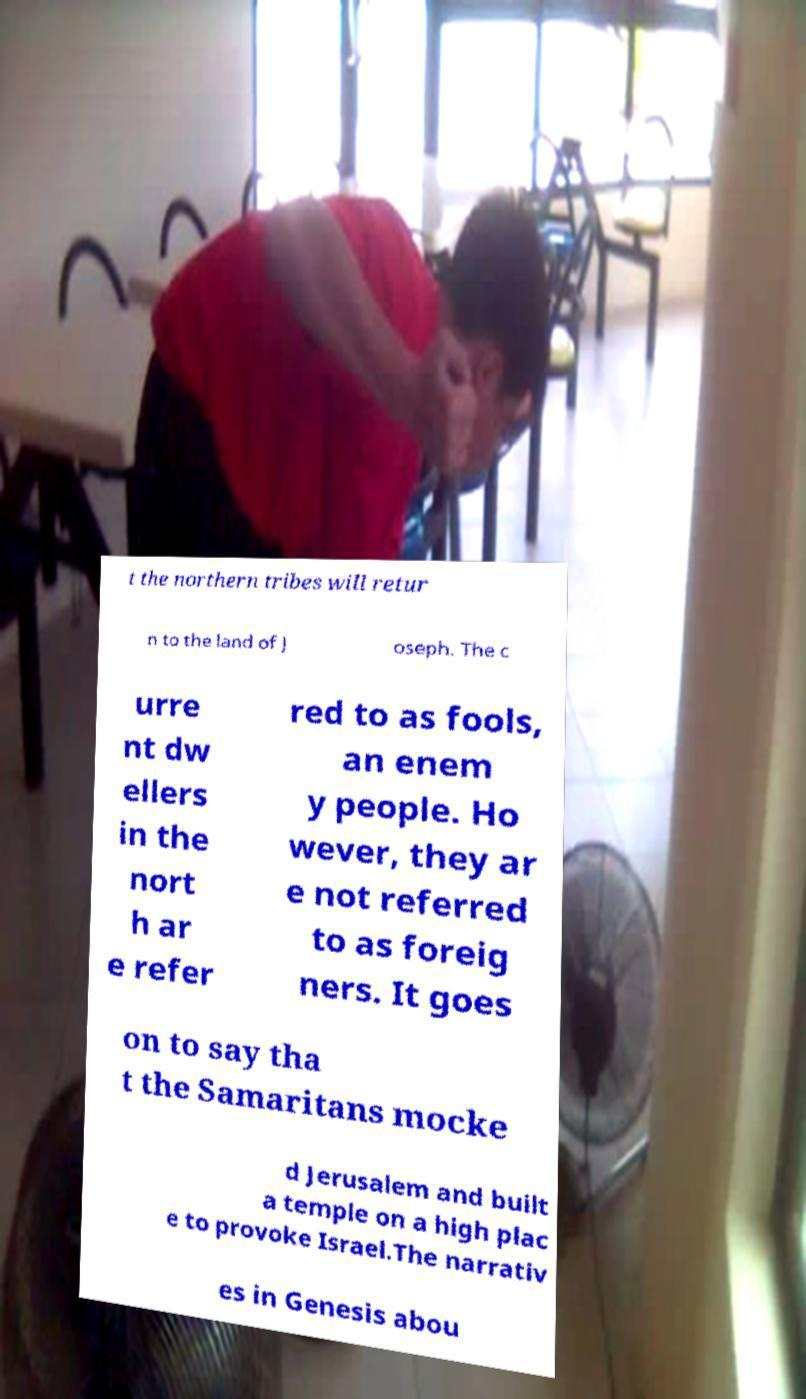What messages or text are displayed in this image? I need them in a readable, typed format. t the northern tribes will retur n to the land of J oseph. The c urre nt dw ellers in the nort h ar e refer red to as fools, an enem y people. Ho wever, they ar e not referred to as foreig ners. It goes on to say tha t the Samaritans mocke d Jerusalem and built a temple on a high plac e to provoke Israel.The narrativ es in Genesis abou 